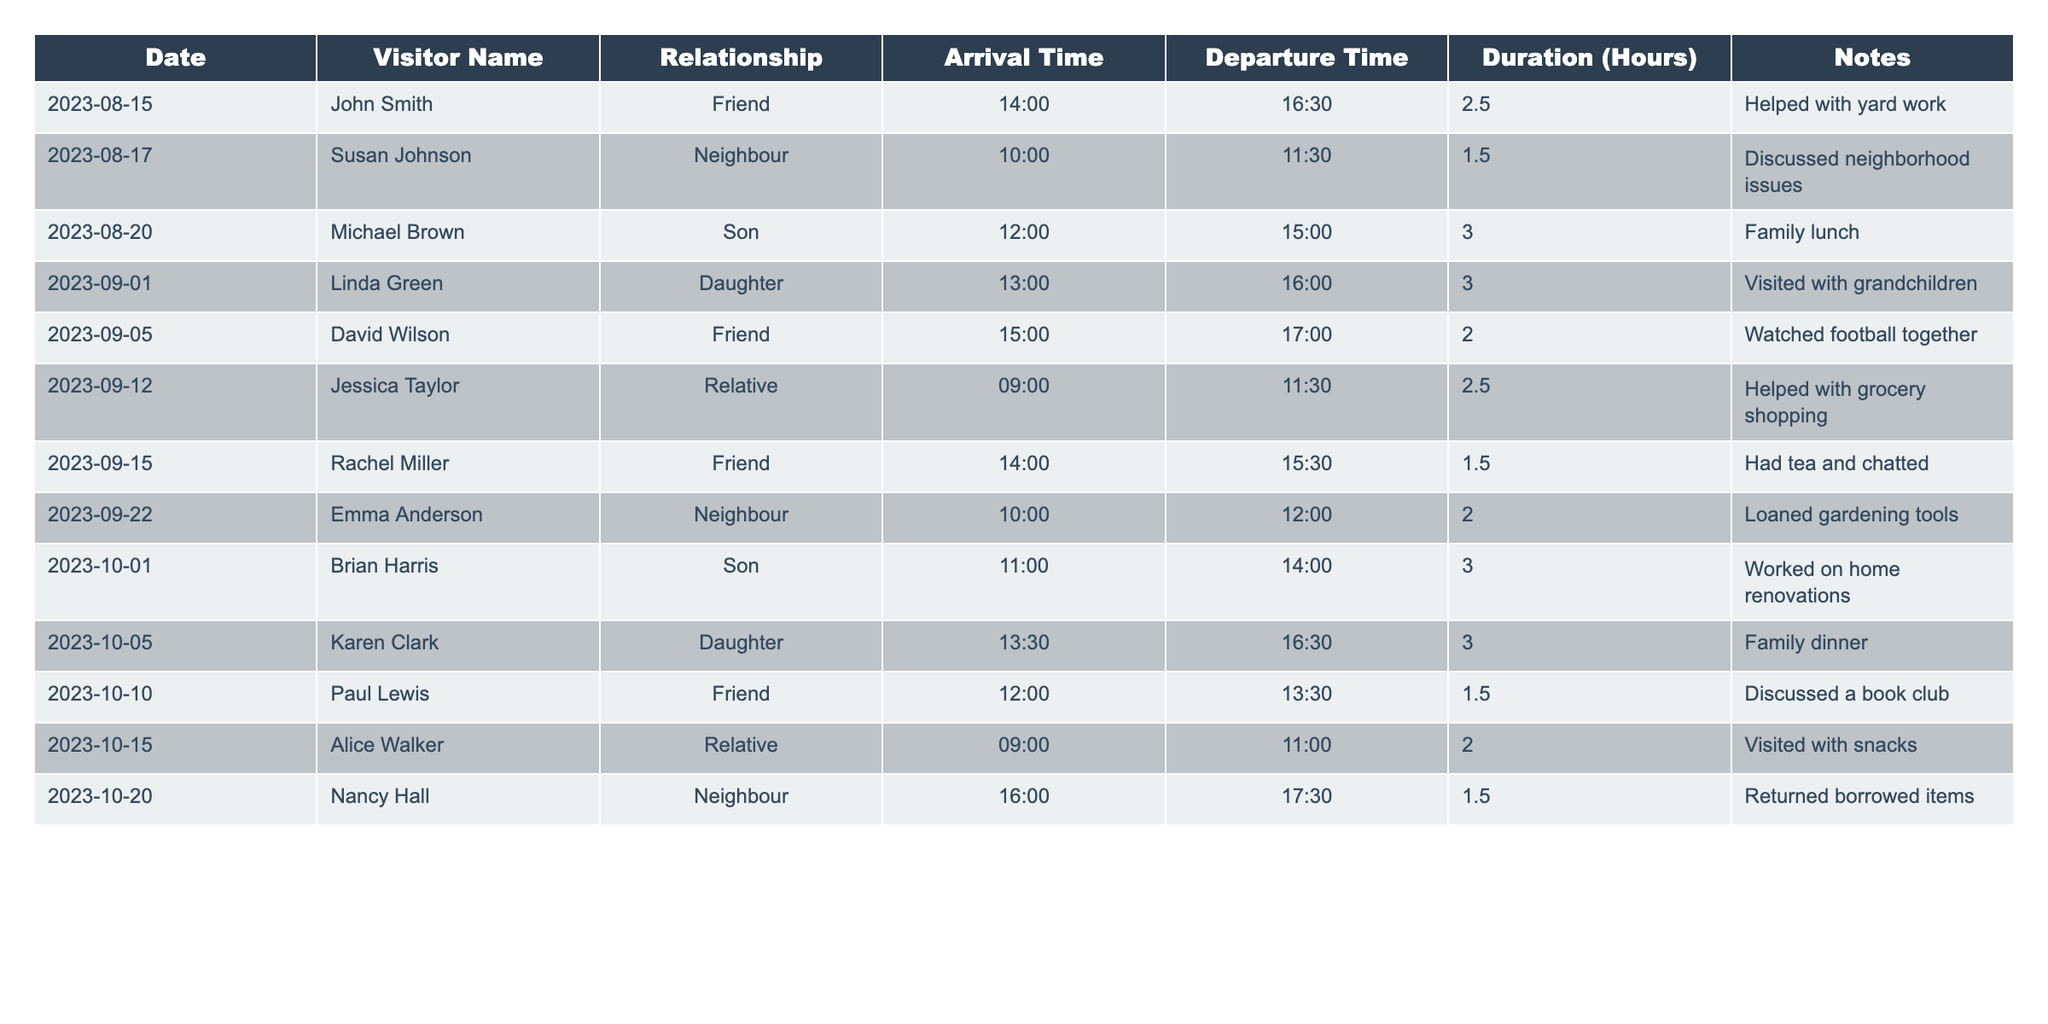What is the name of the visitor who stayed the longest? The visitor with the longest duration is Michael Brown, who stayed for 3.0 hours on August 20.
Answer: Michael Brown How many visitors were there on September 5? According to the table, there was one visitor on September 5: David Wilson.
Answer: 1 What relationship does Emma Anderson have to the household? Emma Anderson is listed as a Neighbour in the table.
Answer: Neighbour How many hours did Nancy Hall spend visiting? Nancy Hall visited for 1.5 hours, as indicated in the Duration column for her visit on October 20.
Answer: 1.5 hours What is the average duration of visits from friends? To calculate the average, we sum the durations from all friends: (2.5 + 2.0 + 1.5 + 1.5) = 7.5, and then divide by 4 (the number of visits): 7.5 / 4 = 1.875.
Answer: 1.875 hours Did any visitors help with household tasks? Yes, both John Smith and Jessica Taylor helped: John helped with yard work, and Jessica helped with grocery shopping.
Answer: Yes How many family members visited in total? The family members listed are Michael Brown, Linda Green, and Karen Clark, totaling 3 family members who visited.
Answer: 3 family members Which visitor had the shortest visit duration? The shortest visit duration is 1.5 hours, and this applies to three visitors: Rachel Miller, Paul Lewis, and Nancy Hall.
Answer: 1.5 hours What is the total number of visits recorded in the log? There are a total of 12 visits recorded in the table.
Answer: 12 visits What are the chances of a visitor being a relative? There are 2 relatives out of 12 visitors (Jessica Taylor and Alice Walker), so the probability is 2/12 = 1/6, or approximately 16.67%.
Answer: Approximately 16.67% 